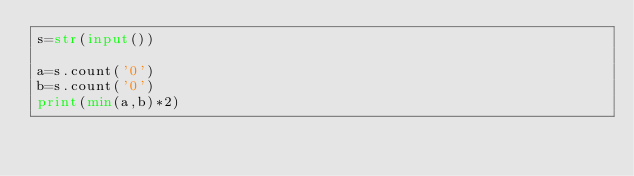Convert code to text. <code><loc_0><loc_0><loc_500><loc_500><_Python_>s=str(input())

a=s.count('0')
b=s.count('0')
print(min(a,b)*2)</code> 